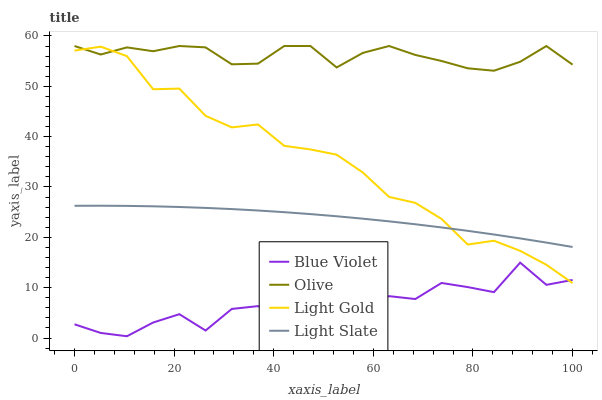Does Blue Violet have the minimum area under the curve?
Answer yes or no. Yes. Does Olive have the maximum area under the curve?
Answer yes or no. Yes. Does Light Slate have the minimum area under the curve?
Answer yes or no. No. Does Light Slate have the maximum area under the curve?
Answer yes or no. No. Is Light Slate the smoothest?
Answer yes or no. Yes. Is Blue Violet the roughest?
Answer yes or no. Yes. Is Light Gold the smoothest?
Answer yes or no. No. Is Light Gold the roughest?
Answer yes or no. No. Does Blue Violet have the lowest value?
Answer yes or no. Yes. Does Light Slate have the lowest value?
Answer yes or no. No. Does Olive have the highest value?
Answer yes or no. Yes. Does Light Slate have the highest value?
Answer yes or no. No. Is Light Slate less than Olive?
Answer yes or no. Yes. Is Olive greater than Light Slate?
Answer yes or no. Yes. Does Olive intersect Light Gold?
Answer yes or no. Yes. Is Olive less than Light Gold?
Answer yes or no. No. Is Olive greater than Light Gold?
Answer yes or no. No. Does Light Slate intersect Olive?
Answer yes or no. No. 